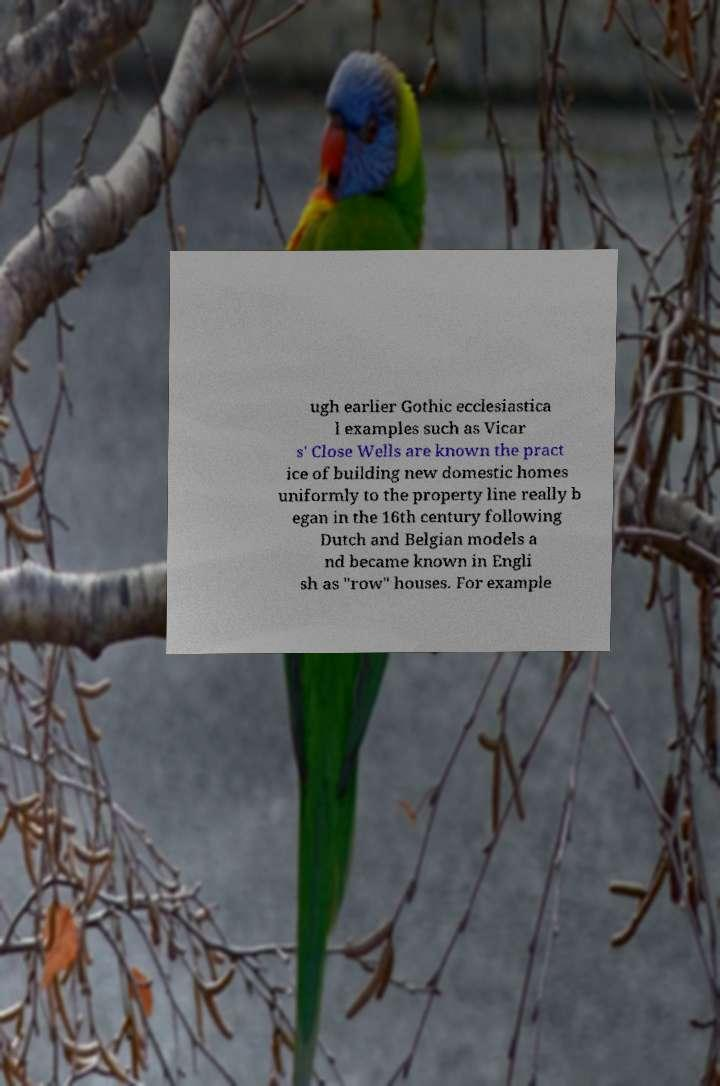Could you assist in decoding the text presented in this image and type it out clearly? ugh earlier Gothic ecclesiastica l examples such as Vicar s' Close Wells are known the pract ice of building new domestic homes uniformly to the property line really b egan in the 16th century following Dutch and Belgian models a nd became known in Engli sh as "row" houses. For example 